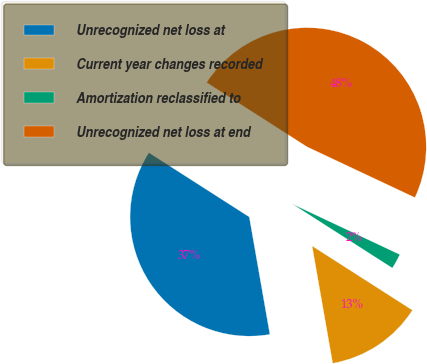<chart> <loc_0><loc_0><loc_500><loc_500><pie_chart><fcel>Unrecognized net loss at<fcel>Current year changes recorded<fcel>Amortization reclassified to<fcel>Unrecognized net loss at end<nl><fcel>36.83%<fcel>13.17%<fcel>2.07%<fcel>47.93%<nl></chart> 